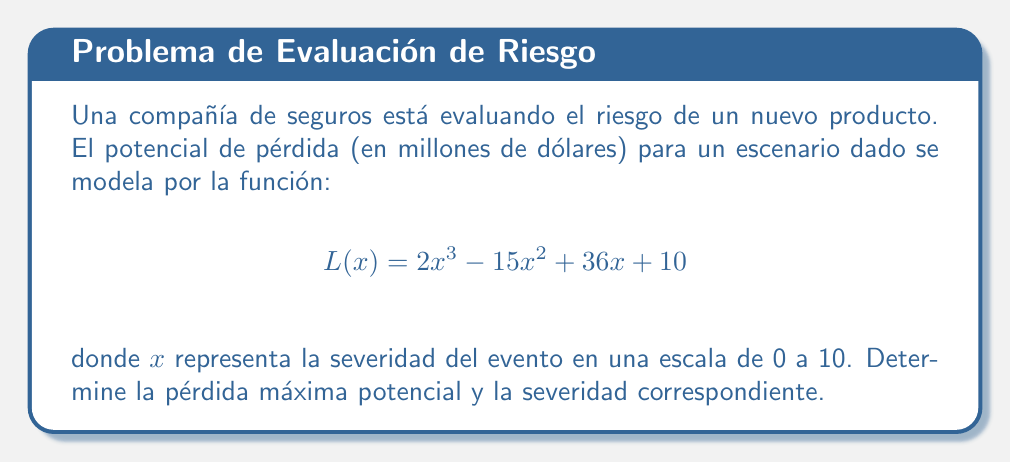What is the answer to this math problem? Para encontrar el máximo de la función $L(x)$, seguiremos estos pasos:

1) Primero, calculamos la derivada de $L(x)$:
   $$L'(x) = 6x^2 - 30x + 36$$

2) Igualamos la derivada a cero para encontrar los puntos críticos:
   $$6x^2 - 30x + 36 = 0$$

3) Resolvemos esta ecuación cuadrática:
   $$x = \frac{30 \pm \sqrt{900 - 864}}{12} = \frac{30 \pm \sqrt{36}}{12} = \frac{30 \pm 6}{12}$$

4) Esto nos da dos puntos críticos:
   $$x_1 = \frac{30 + 6}{12} = 3 \quad \text{y} \quad x_2 = \frac{30 - 6}{12} = 2$$

5) Evaluamos la segunda derivada:
   $$L''(x) = 12x - 30$$

6) Evaluamos $L''(x)$ en los puntos críticos:
   $$L''(3) = 12(3) - 30 = 6 > 0$$
   $$L''(2) = 12(2) - 30 = -6 < 0$$

7) Como $L''(3) > 0$, $x = 3$ es un mínimo local. Como $L''(2) < 0$, $x = 2$ es un máximo local.

8) Evaluamos $L(x)$ en $x = 2$:
   $$L(2) = 2(2)^3 - 15(2)^2 + 36(2) + 10 = 16 - 60 + 72 + 10 = 38$$

9) También evaluamos $L(x)$ en los extremos del intervalo (0 y 10):
   $$L(0) = 10$$
   $$L(10) = 2(10)^3 - 15(10)^2 + 36(10) + 10 = 2000 - 1500 + 360 + 10 = 870$$

10) El máximo global ocurre en $x = 10$ con un valor de 870.
Answer: Pérdida máxima potencial: $870 millones; Severidad correspondiente: 10 